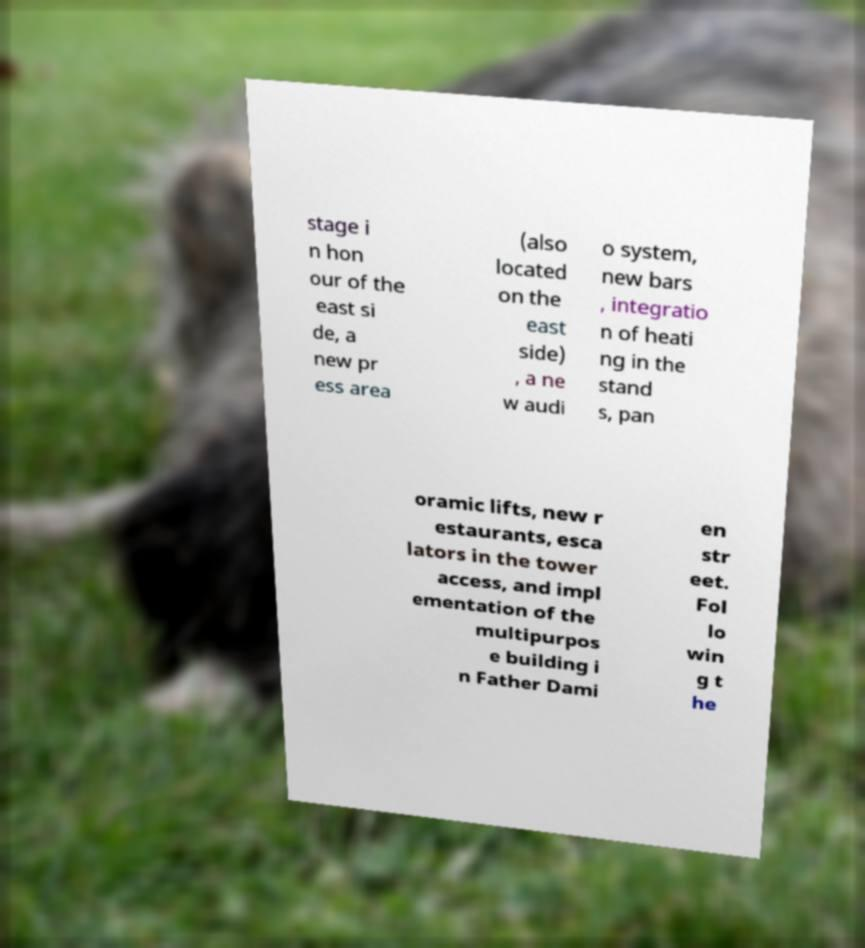What messages or text are displayed in this image? I need them in a readable, typed format. stage i n hon our of the east si de, a new pr ess area (also located on the east side) , a ne w audi o system, new bars , integratio n of heati ng in the stand s, pan oramic lifts, new r estaurants, esca lators in the tower access, and impl ementation of the multipurpos e building i n Father Dami en str eet. Fol lo win g t he 